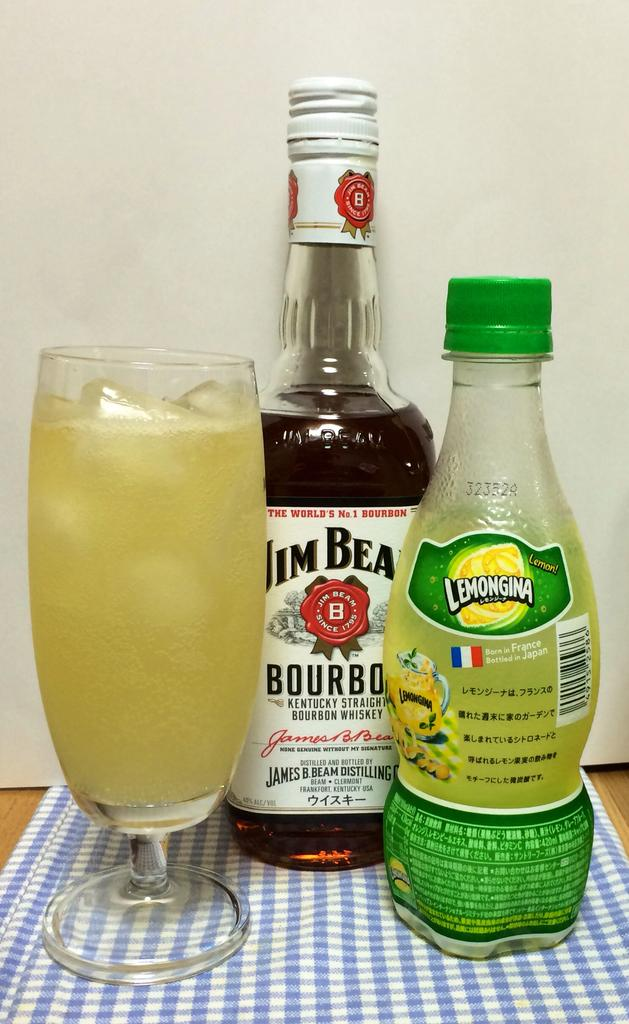What objects can be seen in the image that are made of glass? There is glass in the image, and it is likely that the bottles are made of glass as well. Can you describe the objects made of glass in the image? The image contains bottles made of glass. What is the name of the nation depicted on the calendar in the image? There is no calendar present in the image, so it is not possible to answer that question. 